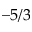Convert formula to latex. <formula><loc_0><loc_0><loc_500><loc_500>- 5 / 3</formula> 